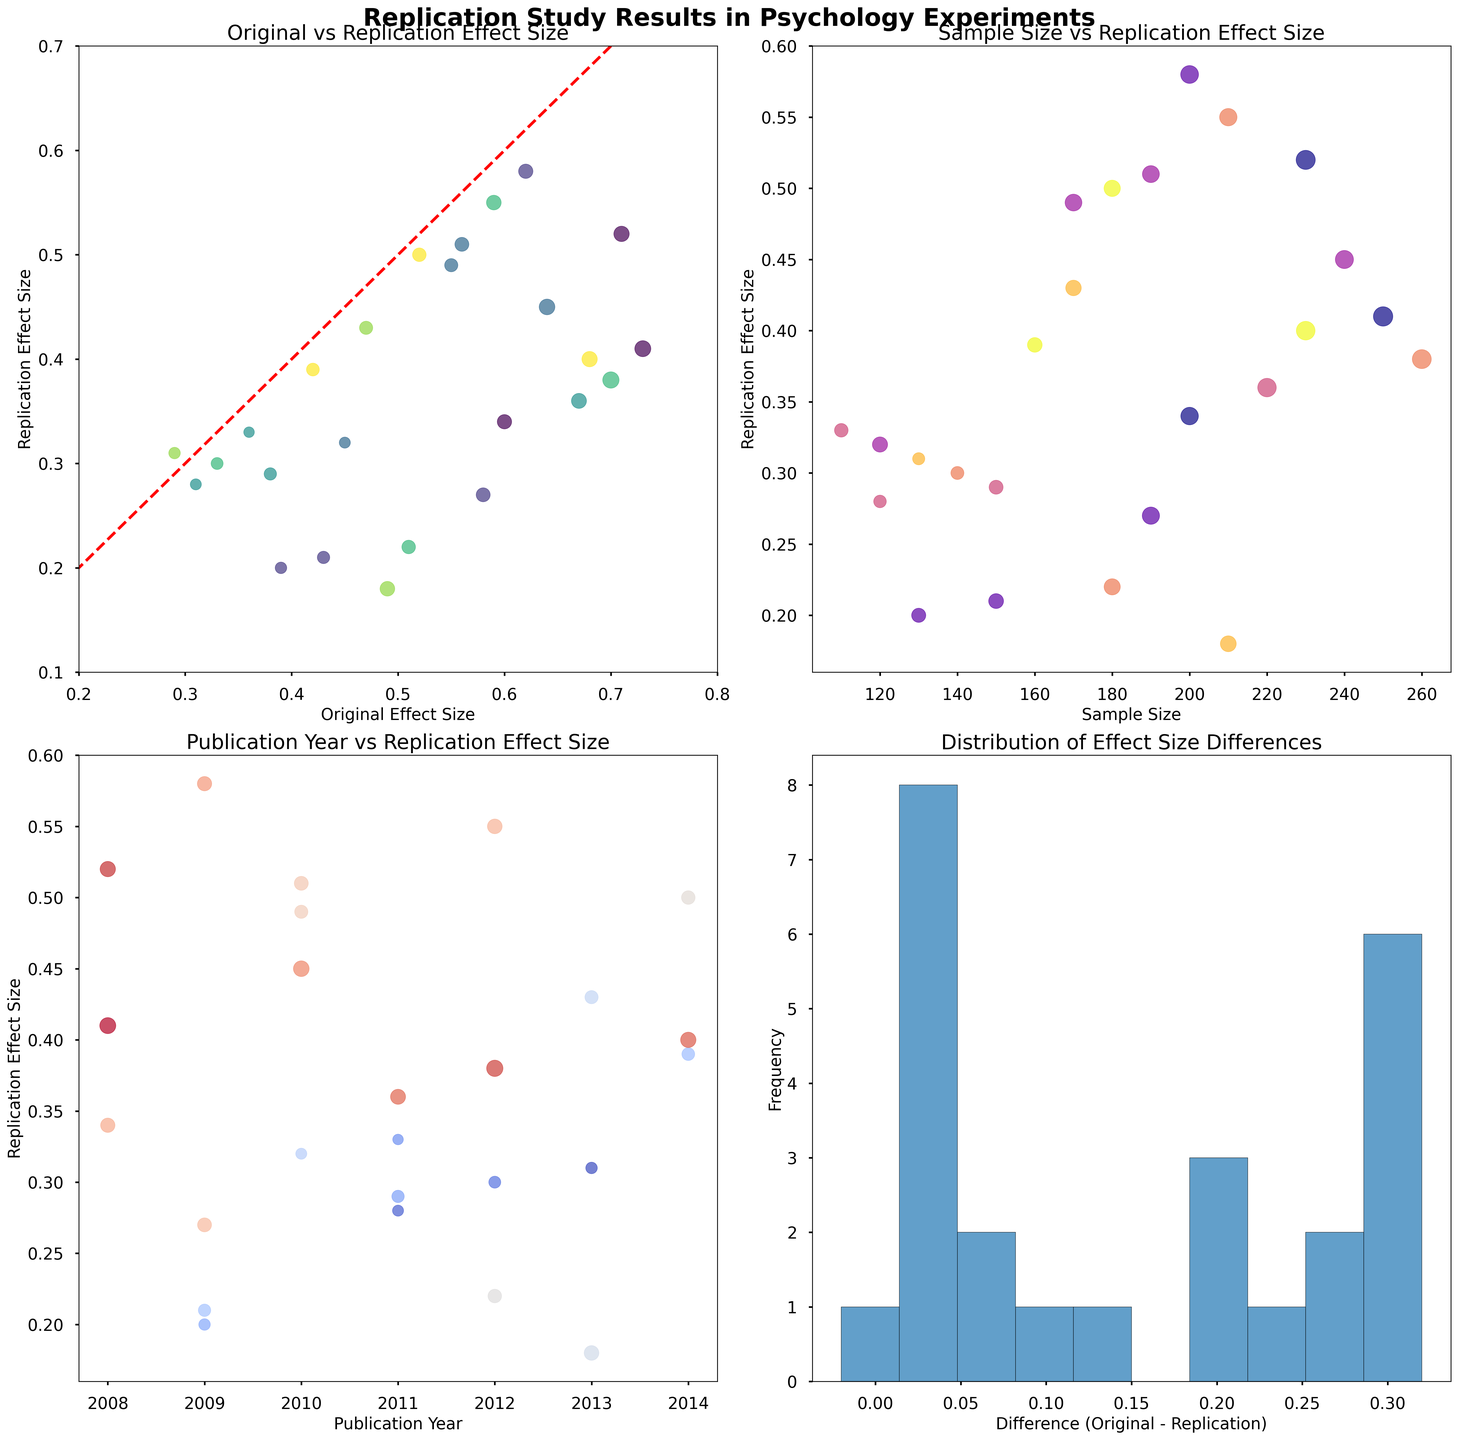How does the replication effect size change with the increase in original effect size? To answer this, look at the scatter plot in the top left. As the original effect size increases, the replication effect size also tends to increase, although it doesn't always match the original and sometimes deviates significantly.
Answer: Increase generally Is there any trend in the replication effect size with respect to the sample size? Look at the scatter plot in the top right. The replication effect size doesn't show a clear trend with the sample size; instead, it varies for different sample sizes.
Answer: No clear trend Which study has the largest difference between the original and replication effect sizes? Refer to the histogram in the bottom right. The bin on the far right has the largest difference (around 0.55), corresponding to study 13 (original 0.49 vs. replication 0.18).
Answer: Study 13 Which year had the most numerous studies with higher replication effect sizes? The scatter plot in the bottom left indicates that the year 2012 has multiple studies with replication effect sizes above 0.40 compared to other years.
Answer: 2012 What is the general distribution of effect size differences (Original - Replication)? Look at the histogram in the bottom right. The majority of effect size differences fall between 0 and 0.4, indicating that replication effect sizes are generally lower than the original ones.
Answer: Between 0 and 0.4 Do studies with larger original effect sizes generally have larger sample sizes? To answer this, examine the top right scatter plot, where larger sample sizes are depicted by bigger marker sizes. Generally, yes, studies with larger original effect sizes tend to have larger sample sizes.
Answer: Generally, yes Is there a consistent pattern between publication year and replication effect size? The scatter plot in the bottom left displays varying replication effect sizes over different years, indicating no consistent pattern or trend based on the publication year.
Answer: No consistent pattern Which studies have a replication effect size very close to their original effect size? In the top left scatter plot, studies close to the diagonal line (red dashed line) have replication effect sizes close to their original effect sizes. Studies like 3, 7, and 16 fit this criterion.
Answer: Studies 3, 7, 16 In which year was the highest original effect size noted? The top left scatter plot uses color to show publication year. The highest original effect size is around 0.73 (study 5) indicated with the color corresponding to the year 2008.
Answer: 2008 